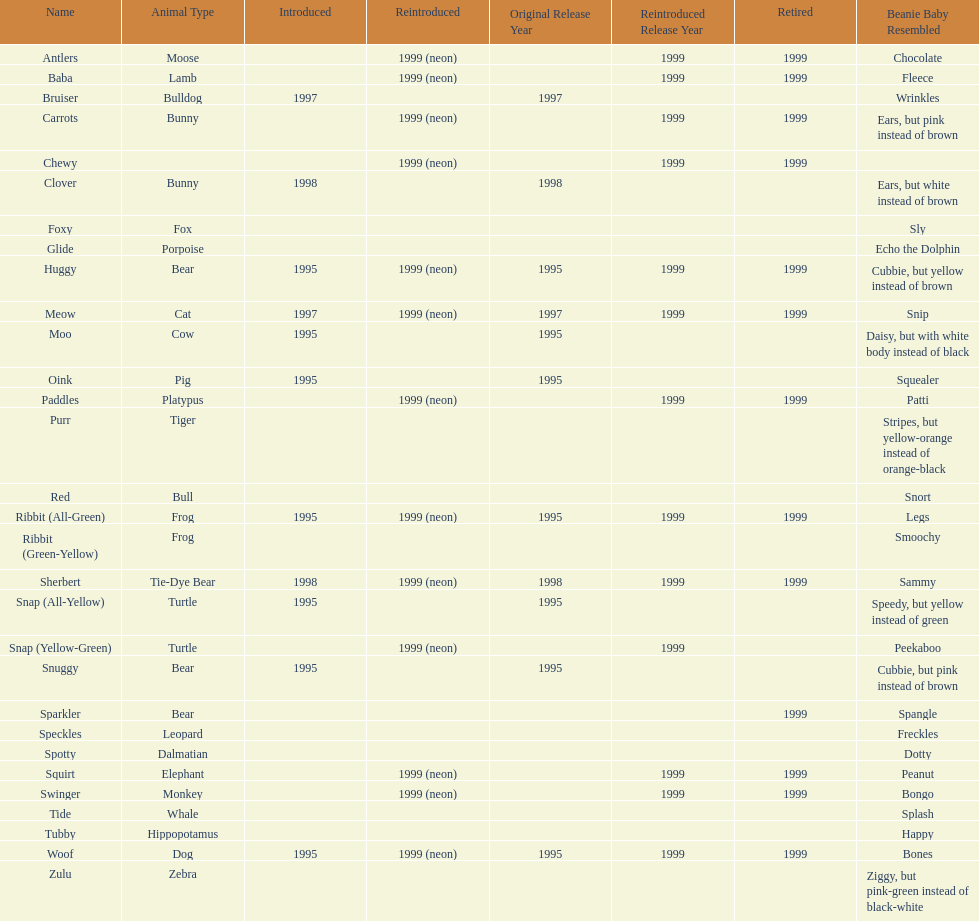Which is the only pillow pal without a listed animal type? Chewy. 